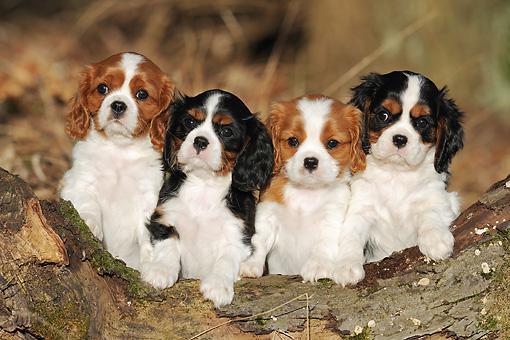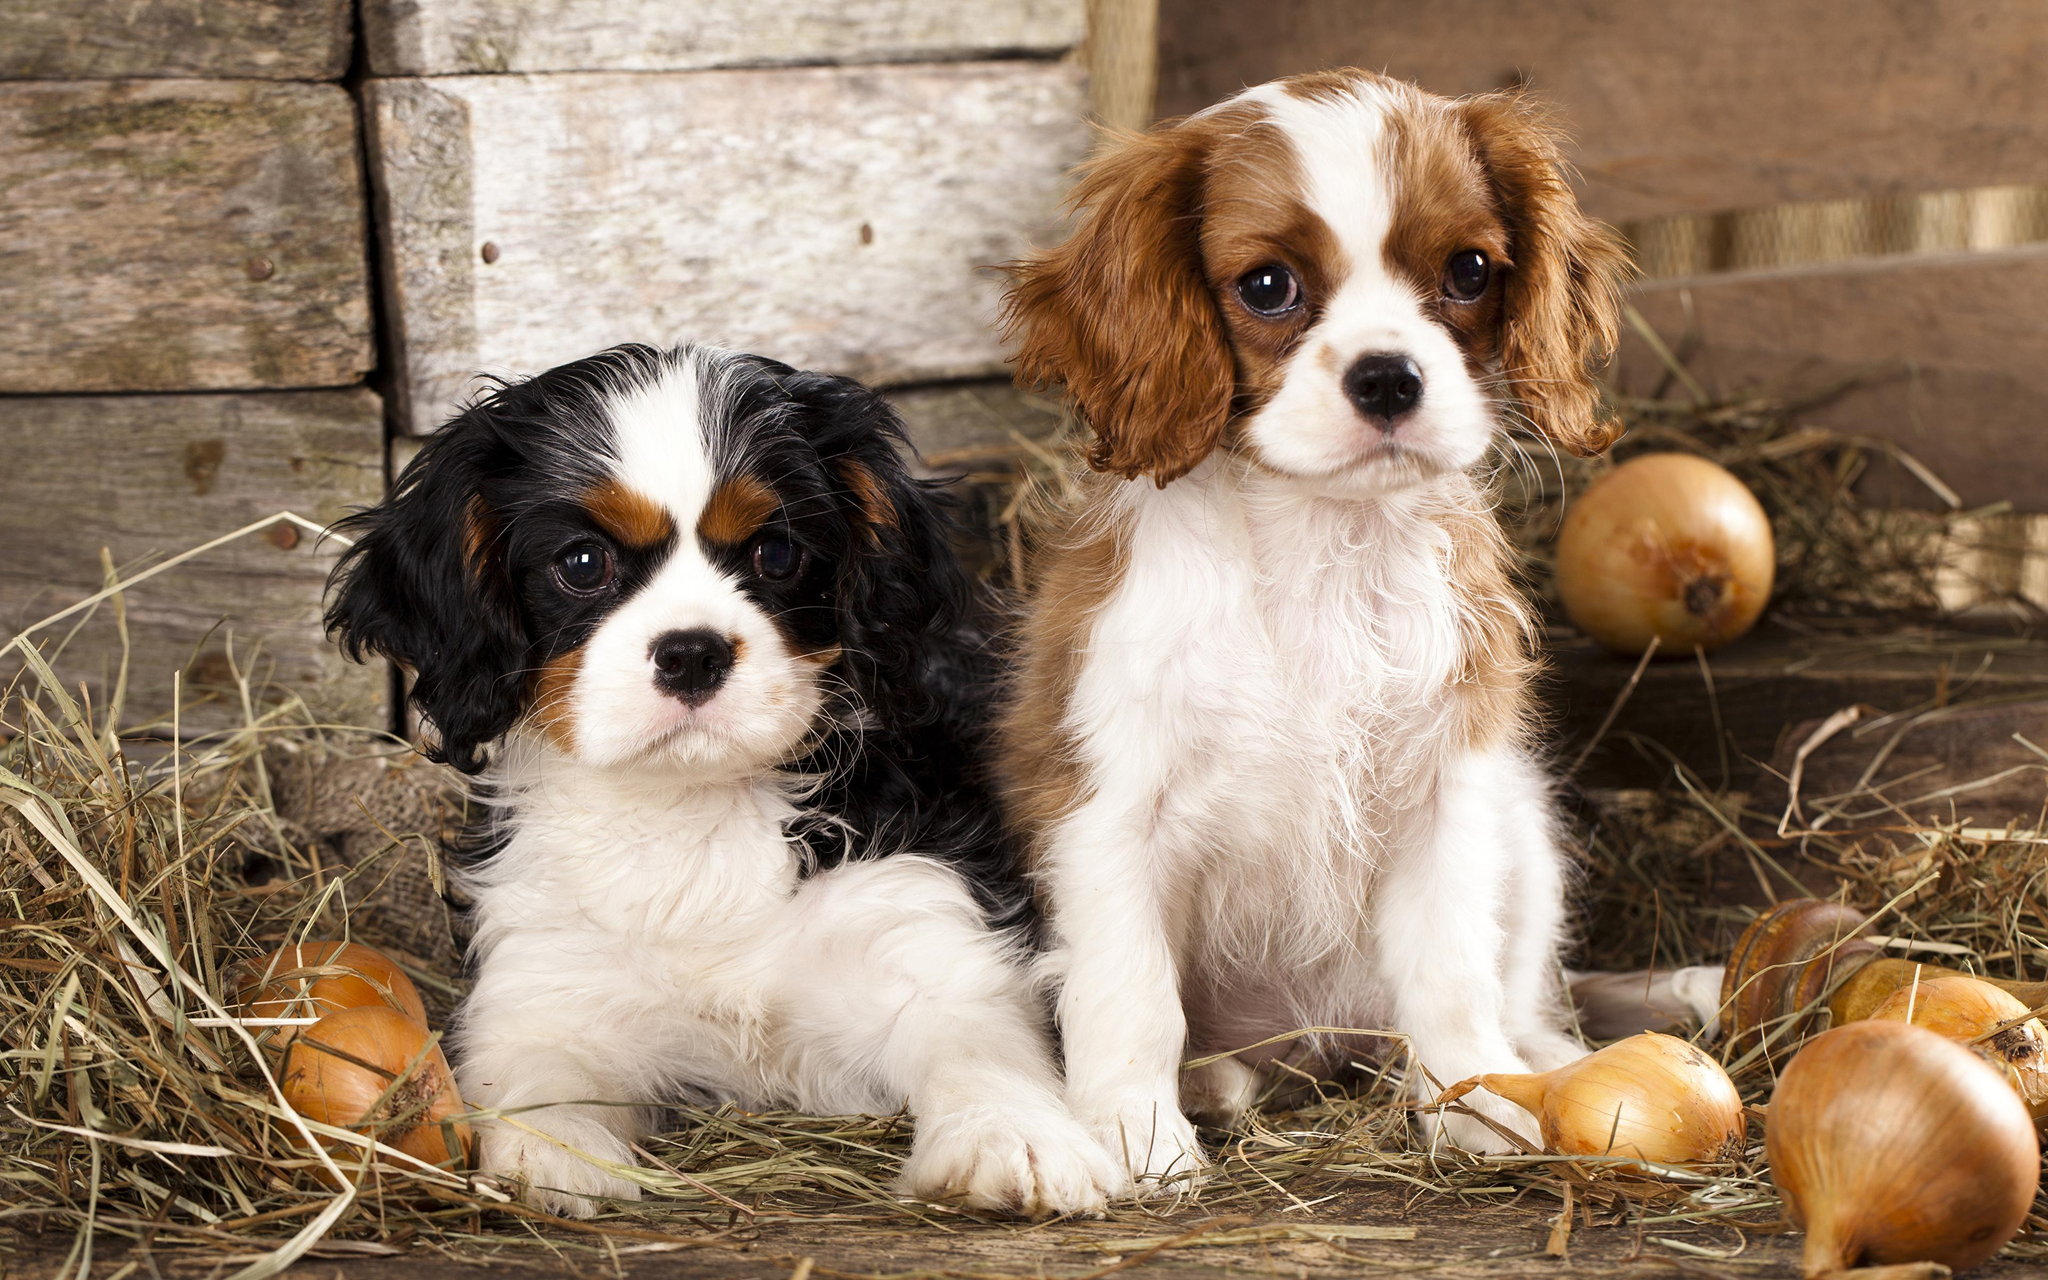The first image is the image on the left, the second image is the image on the right. For the images displayed, is the sentence "All the dogs are lying down and one dog has its head facing towards the left side of the image." factually correct? Answer yes or no. No. The first image is the image on the left, the second image is the image on the right. Examine the images to the left and right. Is the description "There are two dogs, one that is looking forward and one that is not." accurate? Answer yes or no. No. 